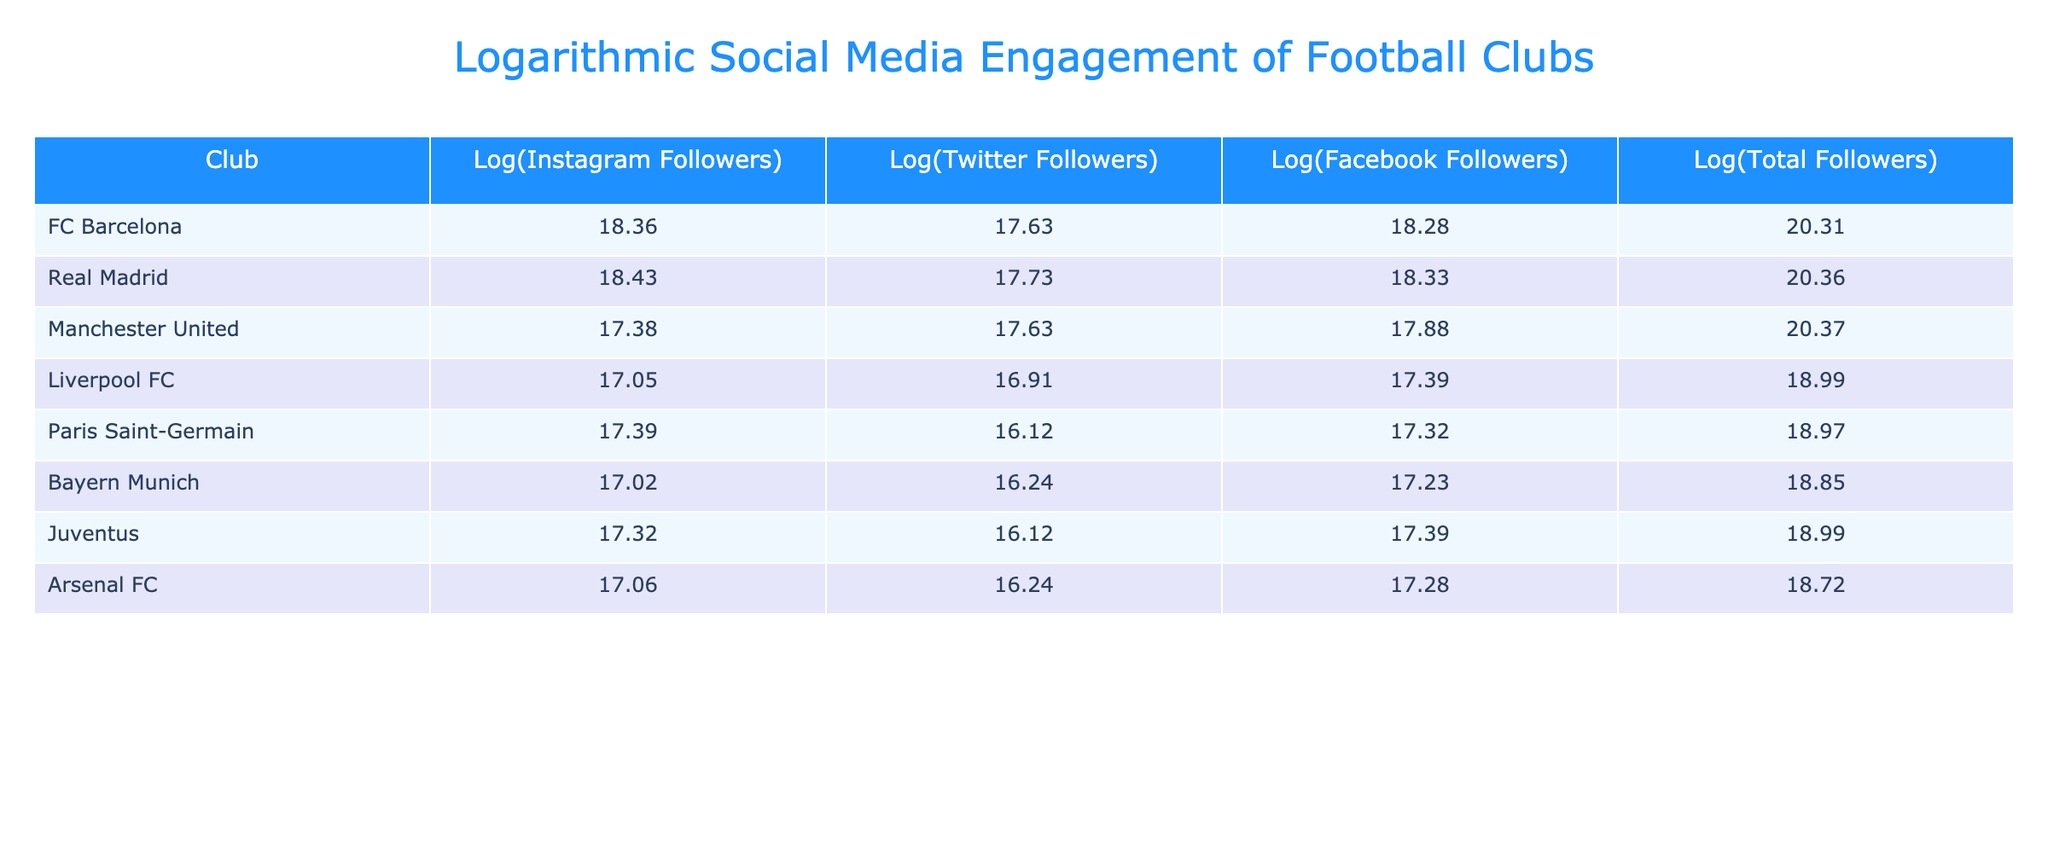What is the total number of followers for Paris Saint-Germain? The total followers for Paris Saint-Germain is listed in the "Total Followers" column. It shows "106M".
Answer: 106M What is the logarithmic value of Twitter followers for FC Barcelona? The logarithmic value for Twitter followers is recorded in the "Log(Twitter Followers)" column. For FC Barcelona, it is "17.63".
Answer: 17.63 Which club has the highest number of followers on Instagram, and what is that value? By comparing the "Instagram Followers" values, Real Madrid has "110M", which is the highest among all clubs.
Answer: Real Madrid, 110M Is the logarithmic value of total followers for Manchester United greater than that for Bayern Munich? The log values are "20.37" for Manchester United and "18.85" for Bayern Munich. Since "20.37" is greater than "18.85", the statement is true.
Answer: Yes What is the average number of Instagram followers for the clubs listed? To find the average, sum the Instagram followers: 108M (FC Barcelona) + 110M (Real Madrid) + 65M (Manchester United) + 37M (Liverpool FC) + 59M (Paris Saint-Germain) + 40M (Bayern Munich) + 52M (Juventus) + 42M (Arsenal FC) = 513M. There are 8 clubs, so the average is 513M / 8 = 64.125M.
Answer: 64.125M How many clubs have more than 100M total followers? By checking the "Total Followers" column, FC Barcelona (253M), Real Madrid (258M), Manchester United (181M), and Liverpool FC (112M) have more than 100M followers. This totals 4 clubs.
Answer: 4 Which club has the lowest logarithmic value for Instagram followers, and what is that value? Comparing the "Log(Instagram Followers)" values, Liverpool FC has the lowest value of "17.05".
Answer: Liverpool FC, 17.05 If we were to sum the logarithmic values of Facebook followers for all clubs, what would that total be? The log values of Facebook followers are 18.28 (FC Barcelona), 18.33 (Real Madrid), 17.88 (Manchester United), 17.39 (Liverpool FC), 17.32 (Paris Saint-Germain), 17.23 (Bayern Munich), 17.39 (Juventus), and 17.28 (Arsenal FC). Adding them together gives us 18.28 + 18.33 + 17.88 + 17.39 + 17.32 + 17.23 + 17.39 + 17.28 = 144.10.
Answer: 144.10 